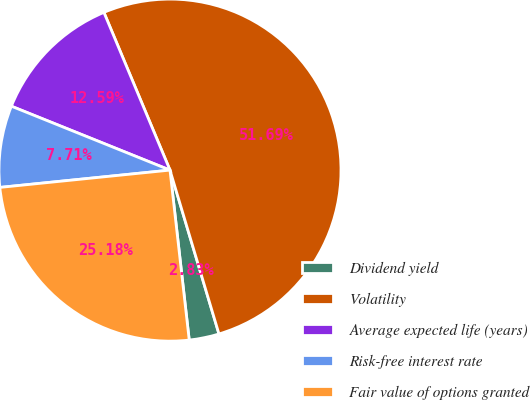Convert chart. <chart><loc_0><loc_0><loc_500><loc_500><pie_chart><fcel>Dividend yield<fcel>Volatility<fcel>Average expected life (years)<fcel>Risk-free interest rate<fcel>Fair value of options granted<nl><fcel>2.83%<fcel>51.69%<fcel>12.59%<fcel>7.71%<fcel>25.18%<nl></chart> 